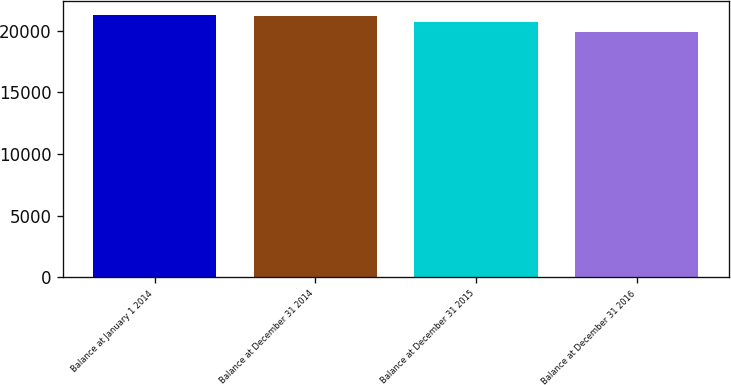Convert chart. <chart><loc_0><loc_0><loc_500><loc_500><bar_chart><fcel>Balance at January 1 2014<fcel>Balance at December 31 2014<fcel>Balance at December 31 2015<fcel>Balance at December 31 2016<nl><fcel>21318.3<fcel>21189<fcel>20702<fcel>19932<nl></chart> 